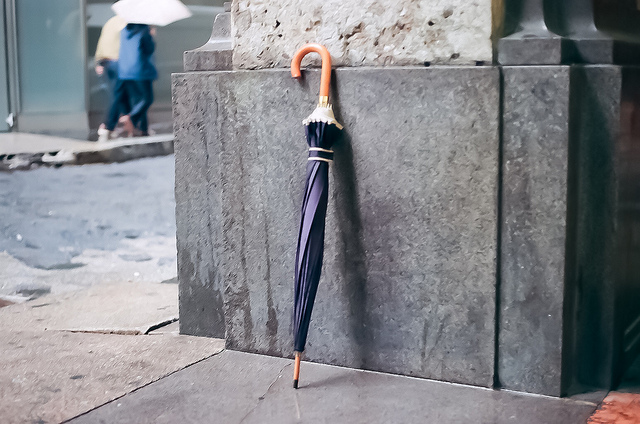What color is the umbrella? The umbrella is primarily dark blue with some hints of lighter blue, and it has an elegant wooden handle with an orange accent. 